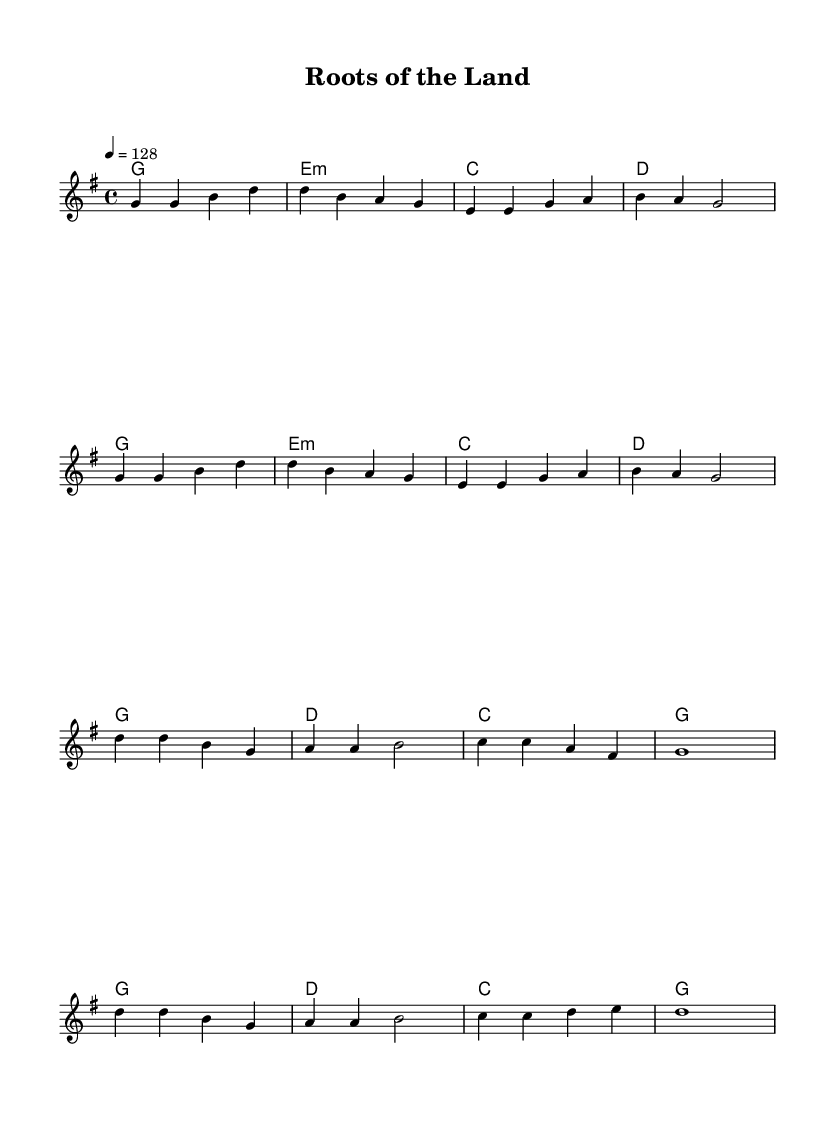What is the key signature of this music? The key signature indicated in the sheet music is G major, which has one sharp (F#).
Answer: G major What is the time signature of this music? The time signature displayed in the sheet music is 4/4, meaning there are four beats in each measure and a quarter note gets one beat.
Answer: 4/4 What is the tempo marking for this piece? The tempo marking shows that the piece should be played at a speed of 128 beats per minute, indicated by the notation "4 = 128".
Answer: 128 How many measures are in the verse section? By counting the measures in the verse section, we see there are 8 measures in total based on the notation provided.
Answer: 8 Which chords are used in the chorus? The chords in the chorus are G, D, C, and G, which corresponds to the chord sequence shown in the harmonies section of the music.
Answer: G, D, C What is the melodic range of the song? The melody starts from G in the octave above middle C and goes to D in the higher octave, indicating a range spanning over an octave.
Answer: One octave What is the thematic focus of the lyrics? While the lyrics are not provided, the title "Roots of the Land" suggests themes related to agriculture and rural life, reflecting traditional farming practices.
Answer: Traditional farming 